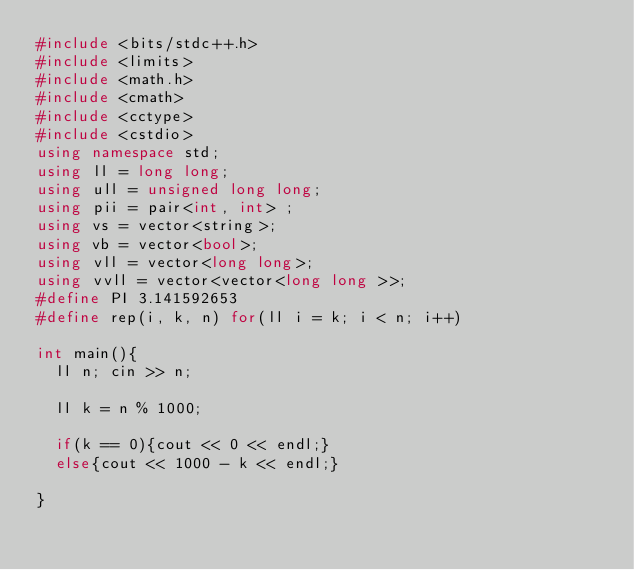Convert code to text. <code><loc_0><loc_0><loc_500><loc_500><_C++_>#include <bits/stdc++.h>
#include <limits>
#include <math.h>
#include <cmath>
#include <cctype>
#include <cstdio>
using namespace std;
using ll = long long;
using ull = unsigned long long;
using pii = pair<int, int> ;
using vs = vector<string>;
using vb = vector<bool>;
using vll = vector<long long>;
using vvll = vector<vector<long long >>;
#define PI 3.141592653
#define rep(i, k, n) for(ll i = k; i < n; i++)

int main(){
  ll n; cin >> n;

  ll k = n % 1000;
  
  if(k == 0){cout << 0 << endl;}
  else{cout << 1000 - k << endl;}
  
}
</code> 